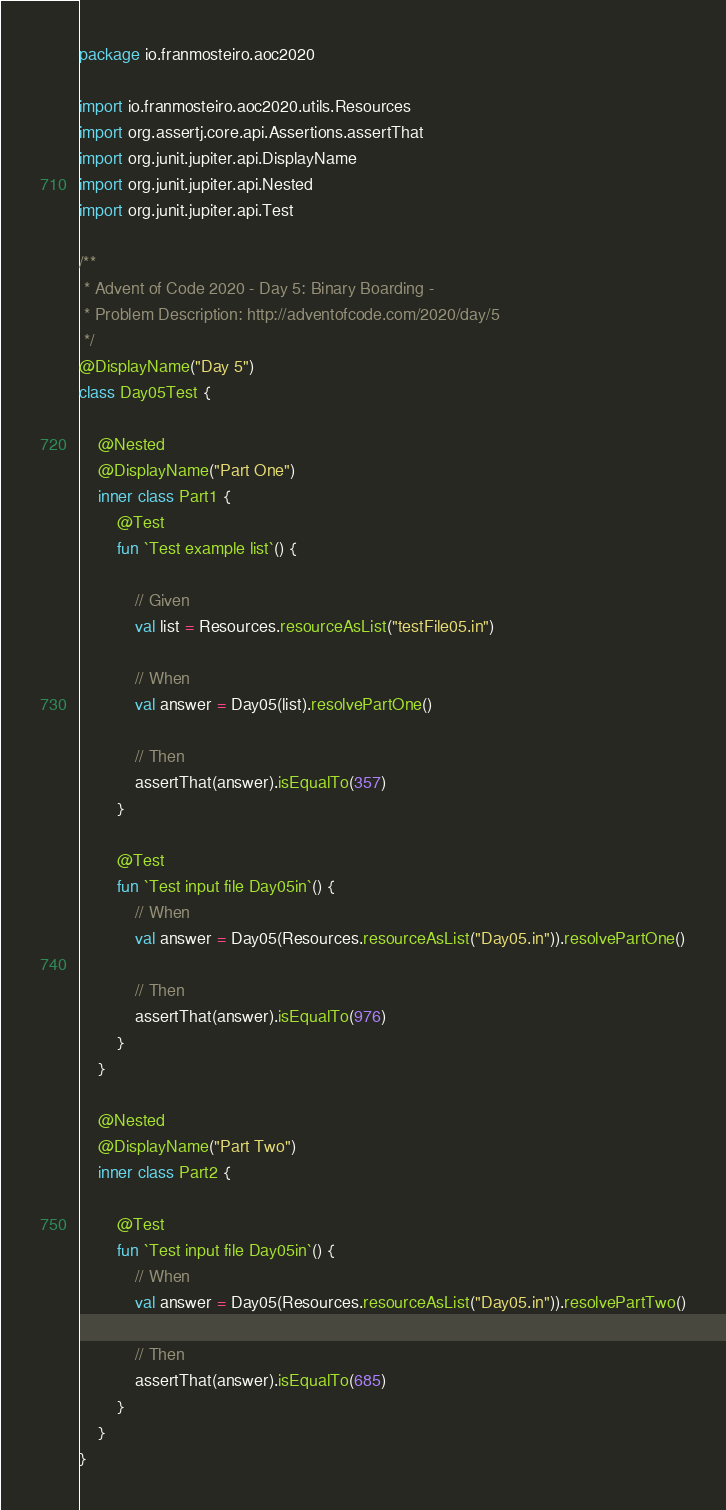Convert code to text. <code><loc_0><loc_0><loc_500><loc_500><_Kotlin_>package io.franmosteiro.aoc2020

import io.franmosteiro.aoc2020.utils.Resources
import org.assertj.core.api.Assertions.assertThat
import org.junit.jupiter.api.DisplayName
import org.junit.jupiter.api.Nested
import org.junit.jupiter.api.Test

/**
 * Advent of Code 2020 - Day 5: Binary Boarding -
 * Problem Description: http://adventofcode.com/2020/day/5
 */
@DisplayName("Day 5")
class Day05Test {

    @Nested
    @DisplayName("Part One")
    inner class Part1 {
        @Test
        fun `Test example list`() {

            // Given
            val list = Resources.resourceAsList("testFile05.in")

            // When
            val answer = Day05(list).resolvePartOne()

            // Then
            assertThat(answer).isEqualTo(357)
        }

        @Test
        fun `Test input file Day05in`() {
            // When
            val answer = Day05(Resources.resourceAsList("Day05.in")).resolvePartOne()

            // Then
            assertThat(answer).isEqualTo(976)
        }
    }

    @Nested
    @DisplayName("Part Two")
    inner class Part2 {

        @Test
        fun `Test input file Day05in`() {
            // When
            val answer = Day05(Resources.resourceAsList("Day05.in")).resolvePartTwo()

            // Then
            assertThat(answer).isEqualTo(685)
        }
    }
}</code> 